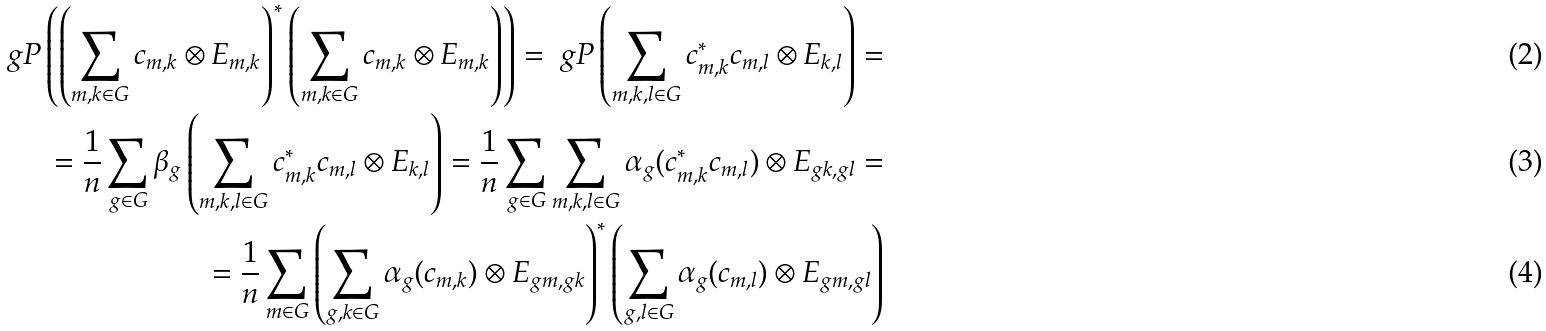<formula> <loc_0><loc_0><loc_500><loc_500>\ g P \left ( \left ( \sum _ { m , k \in G } c _ { m , k } \otimes E _ { m , k } \right ) ^ { * } \left ( \sum _ { m , k \in G } c _ { m , k } \otimes E _ { m , k } \right ) \right ) = \ g P \left ( \sum _ { m , k , l \in G } c _ { m , k } ^ { * } c _ { m , l } \otimes E _ { k , l } \right ) = \\ = \frac { 1 } n \sum _ { g \in G } \beta _ { g } \left ( \sum _ { m , k , l \in G } c _ { m , k } ^ { * } c _ { m , l } \otimes E _ { k , l } \right ) = \frac { 1 } n \sum _ { g \in G } \sum _ { m , k , l \in G } \alpha _ { g } ( c _ { m , k } ^ { * } c _ { m , l } ) \otimes E _ { g k , g l } = \\ = \frac { 1 } n \sum _ { m \in G } \left ( \sum _ { g , k \in G } \alpha _ { g } ( c _ { m , k } ) \otimes E _ { g m , g k } \right ) ^ { * } \left ( \sum _ { g , l \in G } \alpha _ { g } ( c _ { m , l } ) \otimes E _ { g m , g l } \right )</formula> 